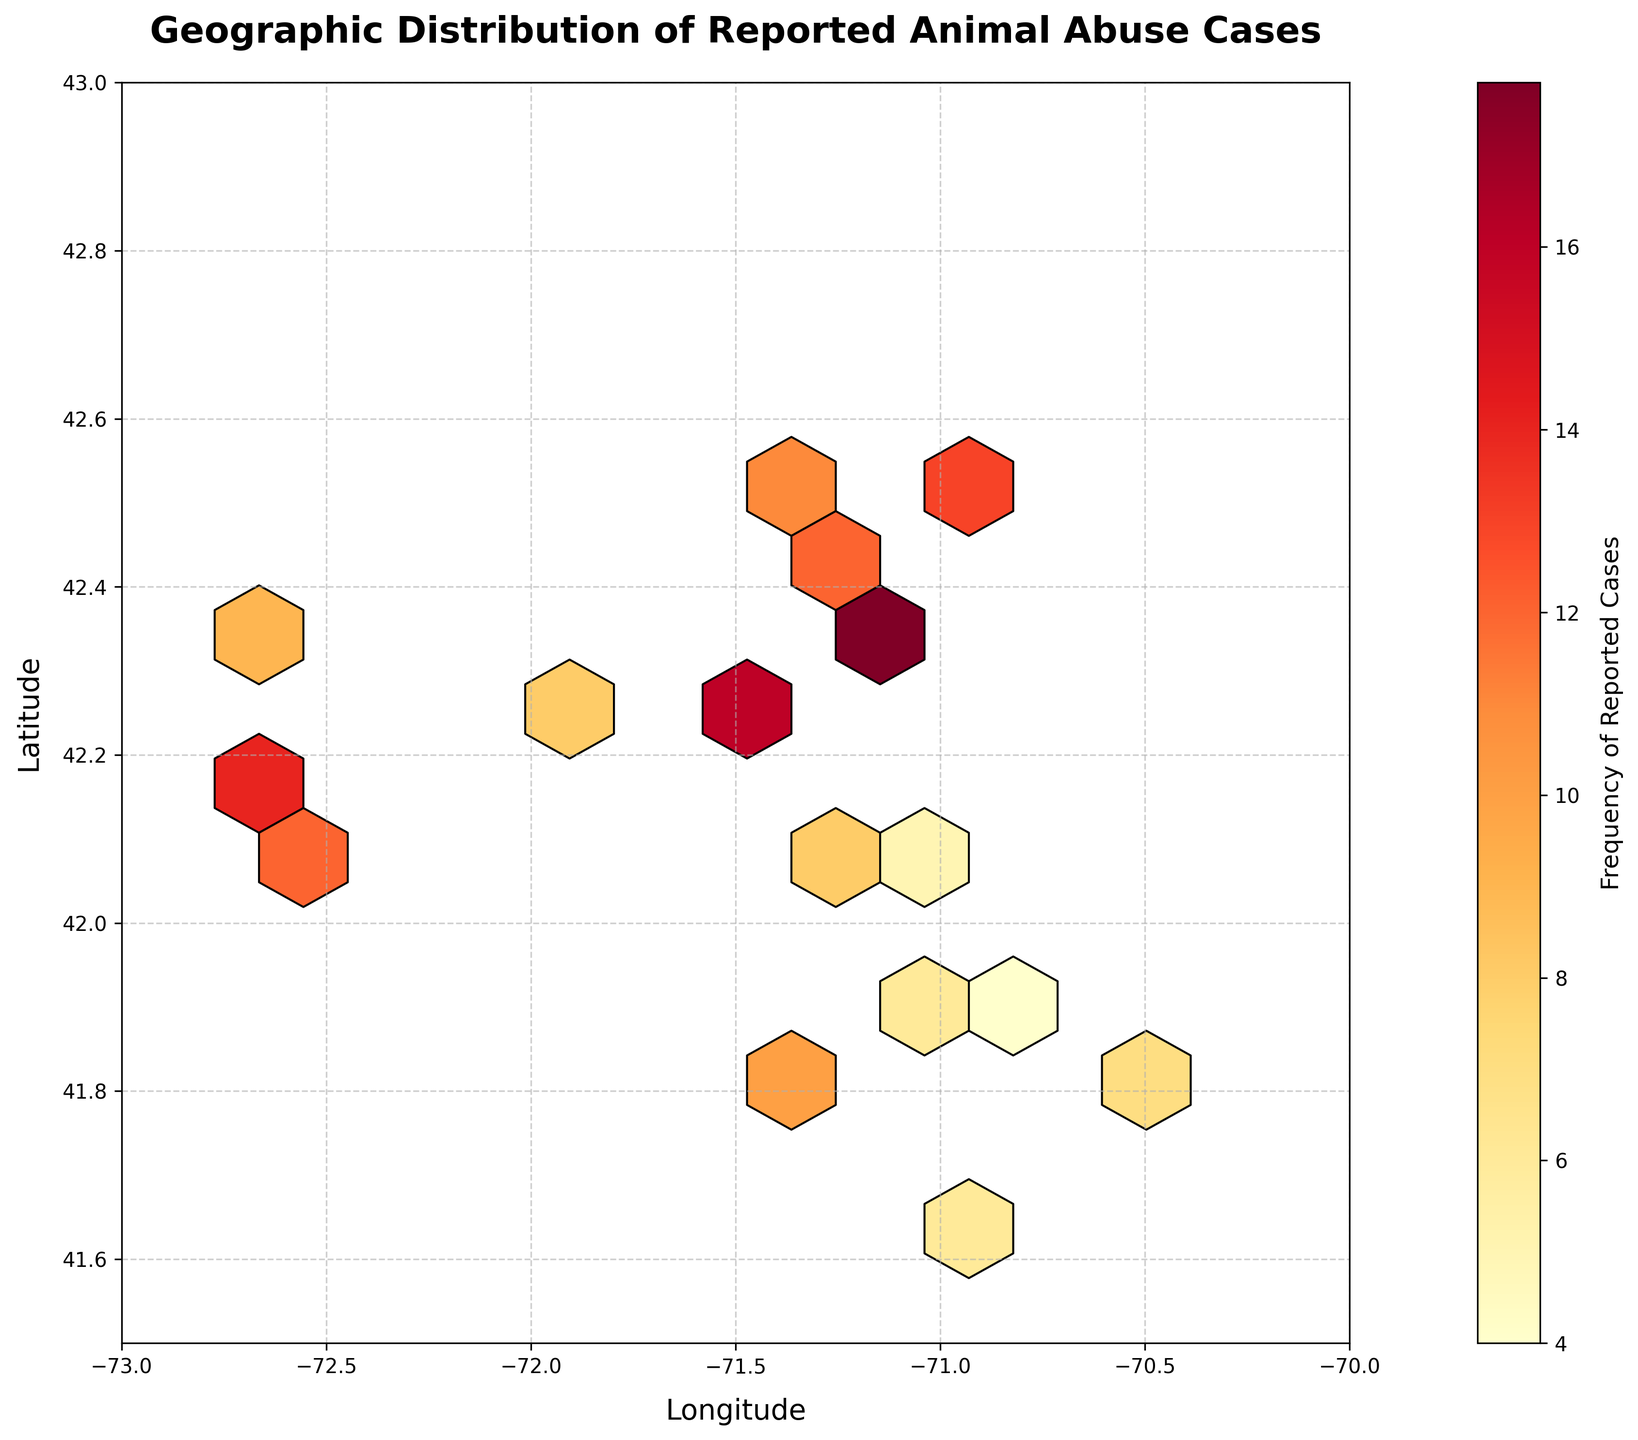what is the title of the plot? the title of the plot is usually located at the top and gives a brief description of what the plot is about. in this case, the title reads "geographic distribution of reported animal abuse cases".
Answer: geographic distribution of reported animal abuse cases what are the labels for the x and y axes? the labels for the x and y axes provide information about what each axis represents. the x-axis is labeled 'longitude', and the y-axis is labeled 'latitude'.
Answer: longitude, latitude how is color used in the hexbin plot? in the hexbin plot, color indicates the frequency of reported animal abuse cases. a color gradient from light yellow to dark red is used, where lighter colors represent lower frequencies and darker colors represent higher frequencies.
Answer: to indicate frequency what color represents the areas with the highest frequency of animal abuse cases? darker red colors represent areas with the highest frequency of animal abuse cases.
Answer: darker red which general region (north, south, east, west) appears to have the highest concentration of animal abuse cases based on the color intensity? observe the plot for regions with darker colors representing higher frequencies. the northeastern part of the state has higher concentrations indicated by redder areas.
Answer: northeast how many bins show a high concentration of reported cases, indicated by dark red? identify and count the bins colored in dark red. there are 2 bins showing a high concentration of reported cases.
Answer: 2 are there any regions with notably low reported cases? regions with lower frequencies are indicated by lighter colors. the southeastern part of the state has lighter colors, representing lower reported cases.
Answer: southeastern part what does the color bar represent? the color bar next to the plot visually represents the frequency of reported animal abuse cases, from low (light yellow) to high (dark red).
Answer: frequency of reported cases which area on the plot has a frequency value significantly higher than its neighboring bins? darker regions can highlight bins with significantly higher frequencies. the area around (42.3751, -71.1150) has a significantly higher frequency compared to its neighbors.
Answer: around (42.3751, -71.1150) how does the frequency of reported cases change as we move from west to east? looking at the color gradient as you move from left to right on the plot can indicate changes in frequency. frequencies increase from lighter to darker colors as you move from west to east.
Answer: increase 